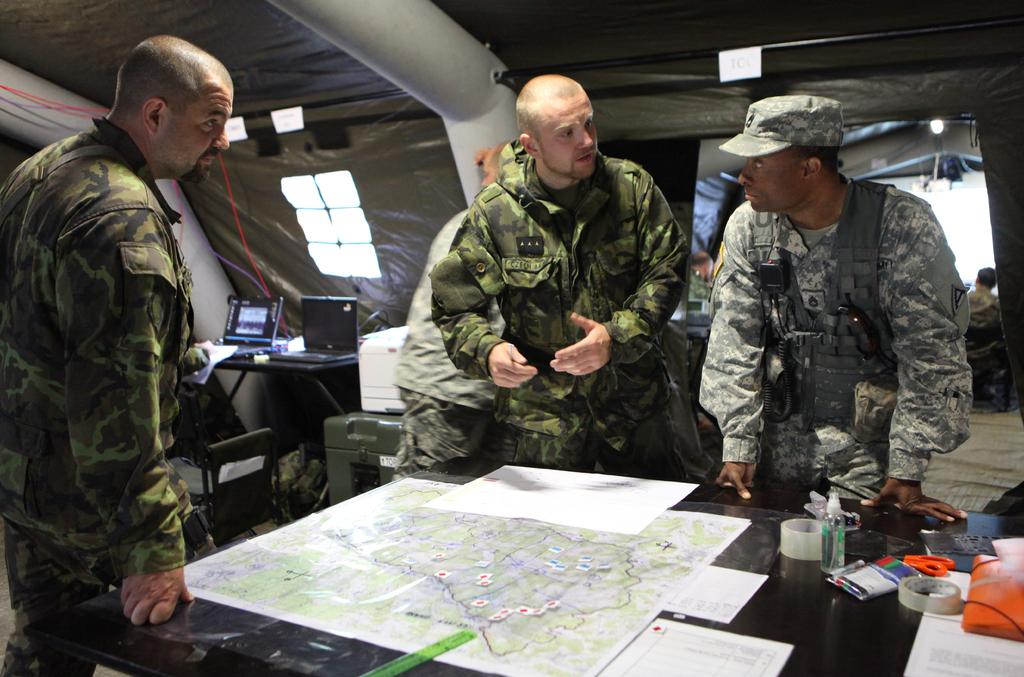What can be seen in the image involving people? There are persons standing in the image. What object related to geography or navigation is present in the image? There is a map in the image. What items are on the table in the image? There are papers and two laptops on the table in the image. What type of celery is being used as a prop in the image? There is no celery present in the image. What kind of art is being created by the persons standing in the image? The image does not depict any art creation or activity. 